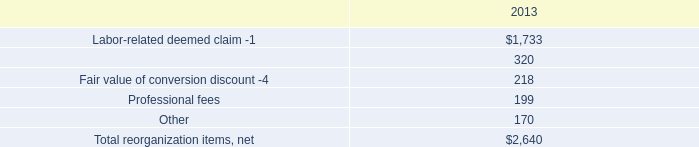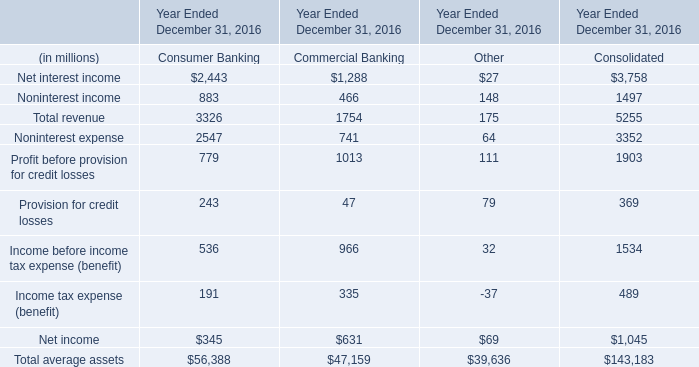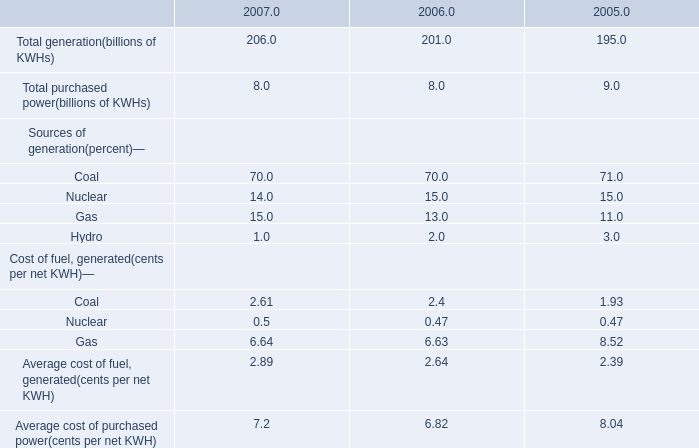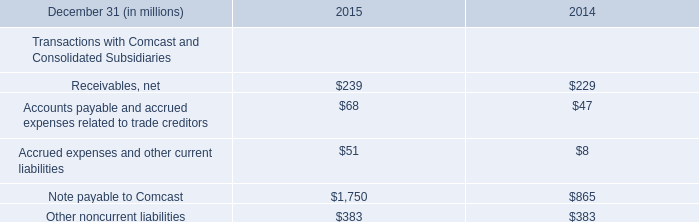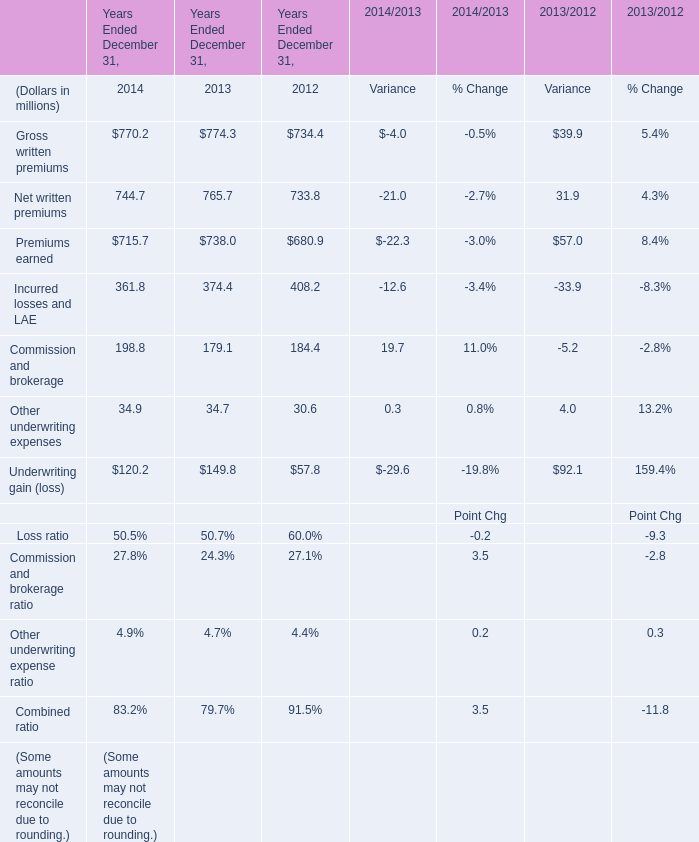What's the sum of Net interest income of Year Ended December 31, 2016 Consolidated, Note payable to Comcast of 2015, and Total revenue of Year Ended December 31, 2016 Consolidated ? 
Computations: ((3758.0 + 1750.0) + 5255.0)
Answer: 10763.0. 